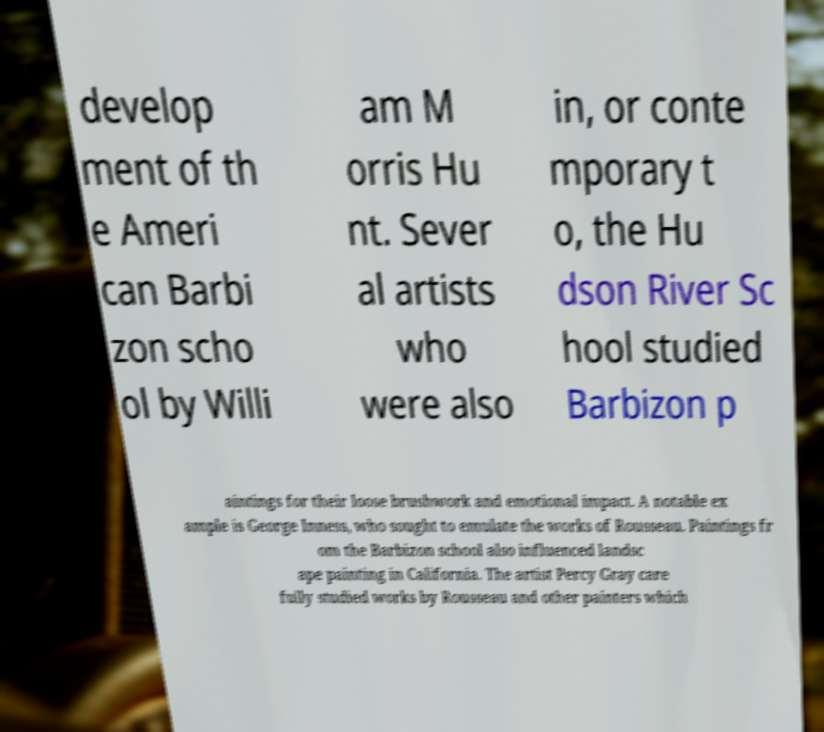Can you accurately transcribe the text from the provided image for me? develop ment of th e Ameri can Barbi zon scho ol by Willi am M orris Hu nt. Sever al artists who were also in, or conte mporary t o, the Hu dson River Sc hool studied Barbizon p aintings for their loose brushwork and emotional impact. A notable ex ample is George Inness, who sought to emulate the works of Rousseau. Paintings fr om the Barbizon school also influenced landsc ape painting in California. The artist Percy Gray care fully studied works by Rousseau and other painters which 